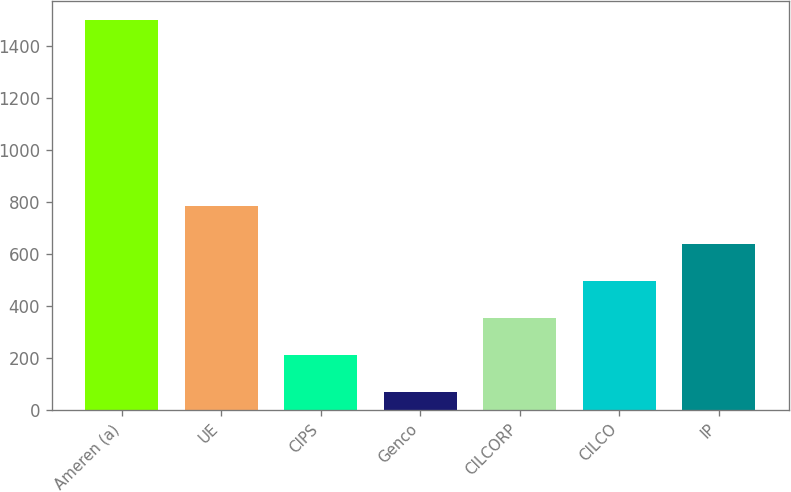Convert chart to OTSL. <chart><loc_0><loc_0><loc_500><loc_500><bar_chart><fcel>Ameren (a)<fcel>UE<fcel>CIPS<fcel>Genco<fcel>CILCORP<fcel>CILCO<fcel>IP<nl><fcel>1499<fcel>783<fcel>210.2<fcel>67<fcel>353.4<fcel>496.6<fcel>639.8<nl></chart> 